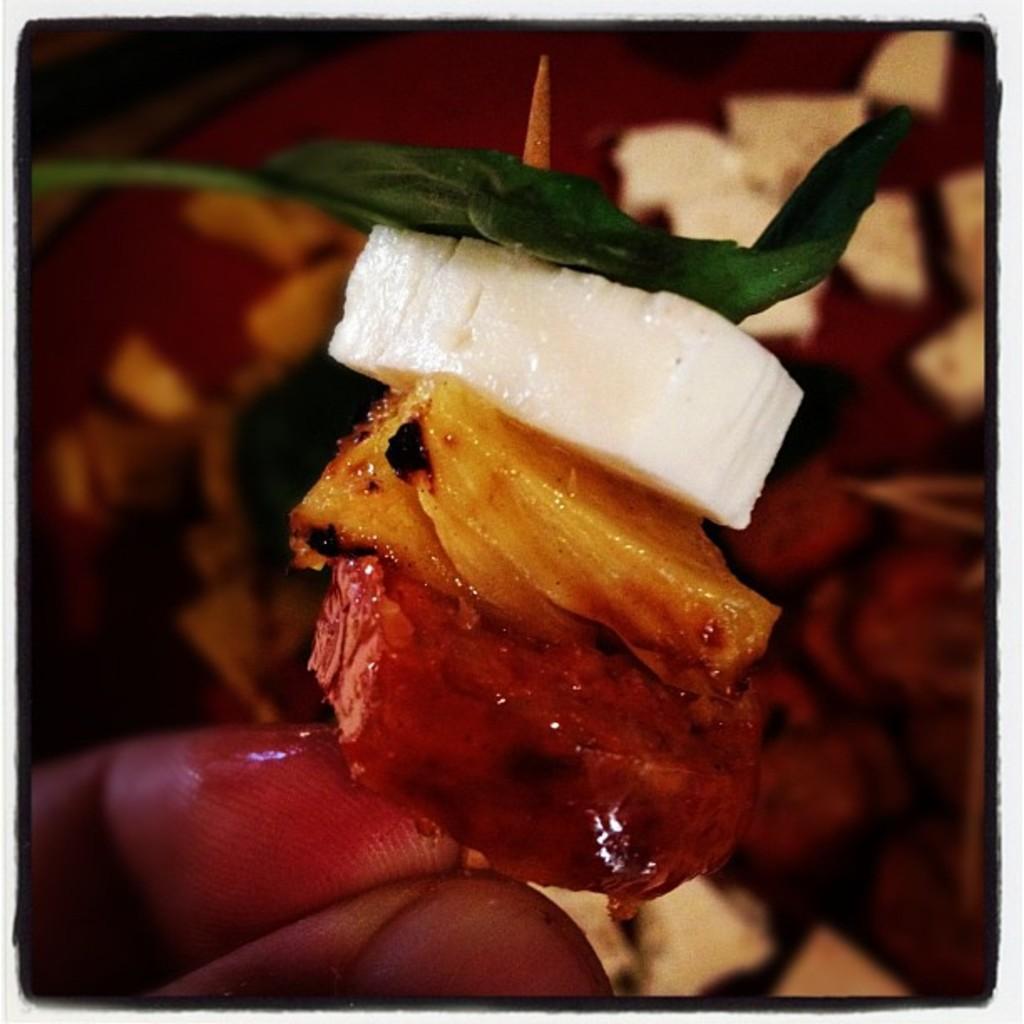Please provide a concise description of this image. In this image in the front there is food on the hand of the person and the background is blurry. 